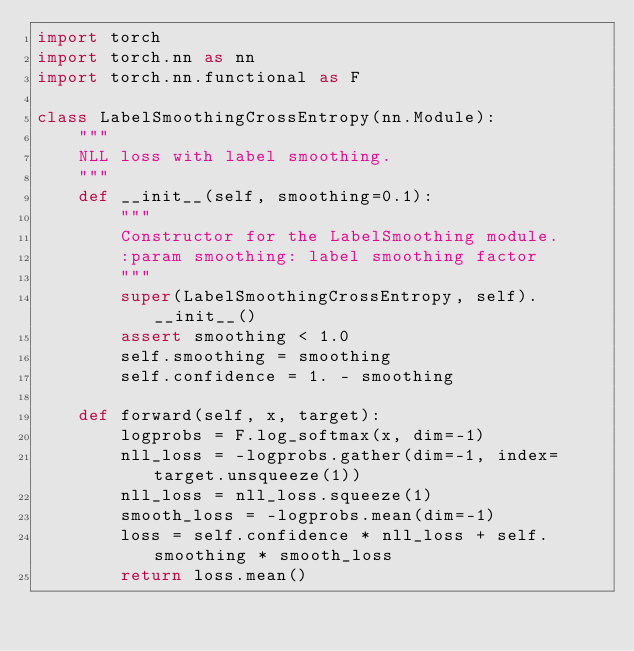<code> <loc_0><loc_0><loc_500><loc_500><_Python_>import torch
import torch.nn as nn
import torch.nn.functional as F

class LabelSmoothingCrossEntropy(nn.Module):
    """
    NLL loss with label smoothing.
    """
    def __init__(self, smoothing=0.1):
        """
        Constructor for the LabelSmoothing module.
        :param smoothing: label smoothing factor
        """
        super(LabelSmoothingCrossEntropy, self).__init__()
        assert smoothing < 1.0
        self.smoothing = smoothing
        self.confidence = 1. - smoothing

    def forward(self, x, target):
        logprobs = F.log_softmax(x, dim=-1)
        nll_loss = -logprobs.gather(dim=-1, index=target.unsqueeze(1))
        nll_loss = nll_loss.squeeze(1)
        smooth_loss = -logprobs.mean(dim=-1)
        loss = self.confidence * nll_loss + self.smoothing * smooth_loss
        return loss.mean()


</code> 